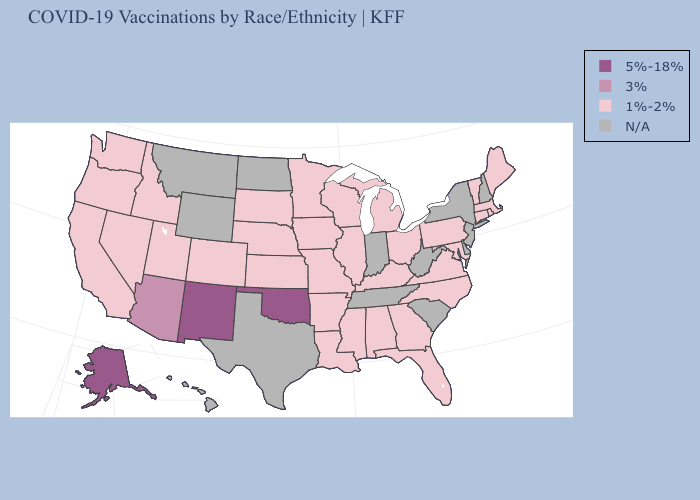What is the lowest value in the South?
Keep it brief. 1%-2%. What is the value of Florida?
Quick response, please. 1%-2%. Name the states that have a value in the range N/A?
Be succinct. Delaware, Hawaii, Indiana, Montana, New Hampshire, New Jersey, New York, North Dakota, South Carolina, Tennessee, Texas, West Virginia, Wyoming. Which states have the lowest value in the South?
Answer briefly. Alabama, Arkansas, Florida, Georgia, Kentucky, Louisiana, Maryland, Mississippi, North Carolina, Virginia. Does the map have missing data?
Quick response, please. Yes. Does Oklahoma have the lowest value in the USA?
Answer briefly. No. Name the states that have a value in the range N/A?
Be succinct. Delaware, Hawaii, Indiana, Montana, New Hampshire, New Jersey, New York, North Dakota, South Carolina, Tennessee, Texas, West Virginia, Wyoming. What is the value of Wyoming?
Quick response, please. N/A. Among the states that border Idaho , which have the lowest value?
Short answer required. Nevada, Oregon, Utah, Washington. What is the value of Minnesota?
Short answer required. 1%-2%. Which states have the highest value in the USA?
Concise answer only. Alaska, New Mexico, Oklahoma. 